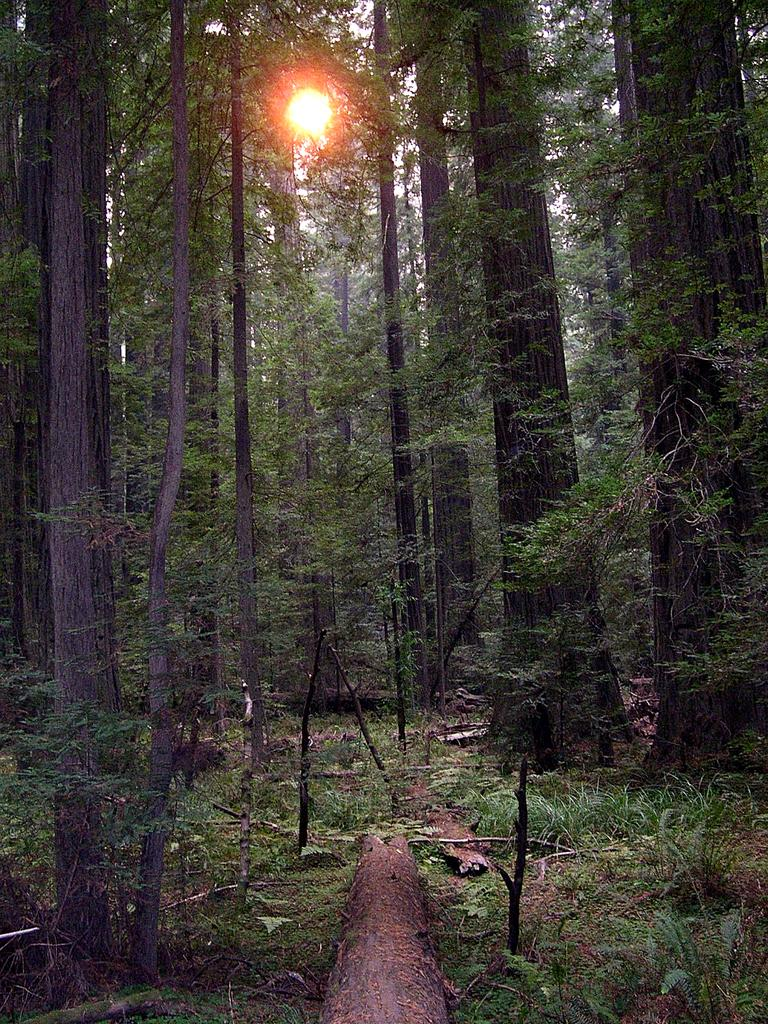What type of vegetation can be seen in the image? There are trees and plants in the image. What is present on the ground in the image? There is wood on the ground in the image. What can be seen in the background of the image? The sunlight and the sky are visible in the background of the image. How many boys are playing near the seashore in the image? There is no seashore or boys present in the image; it features trees, plants, wood, sunlight, and the sky. 